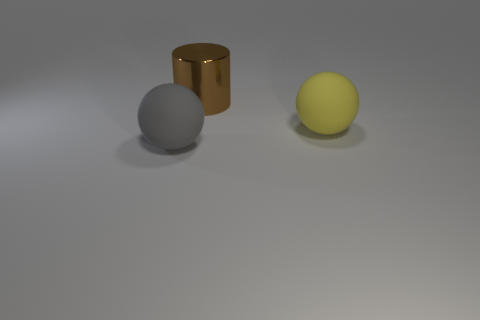Is there anything else that is the same material as the big cylinder? Upon reviewing the image, it seems there are no other objects made of the same glossy, reflective material as the big cylinder. 